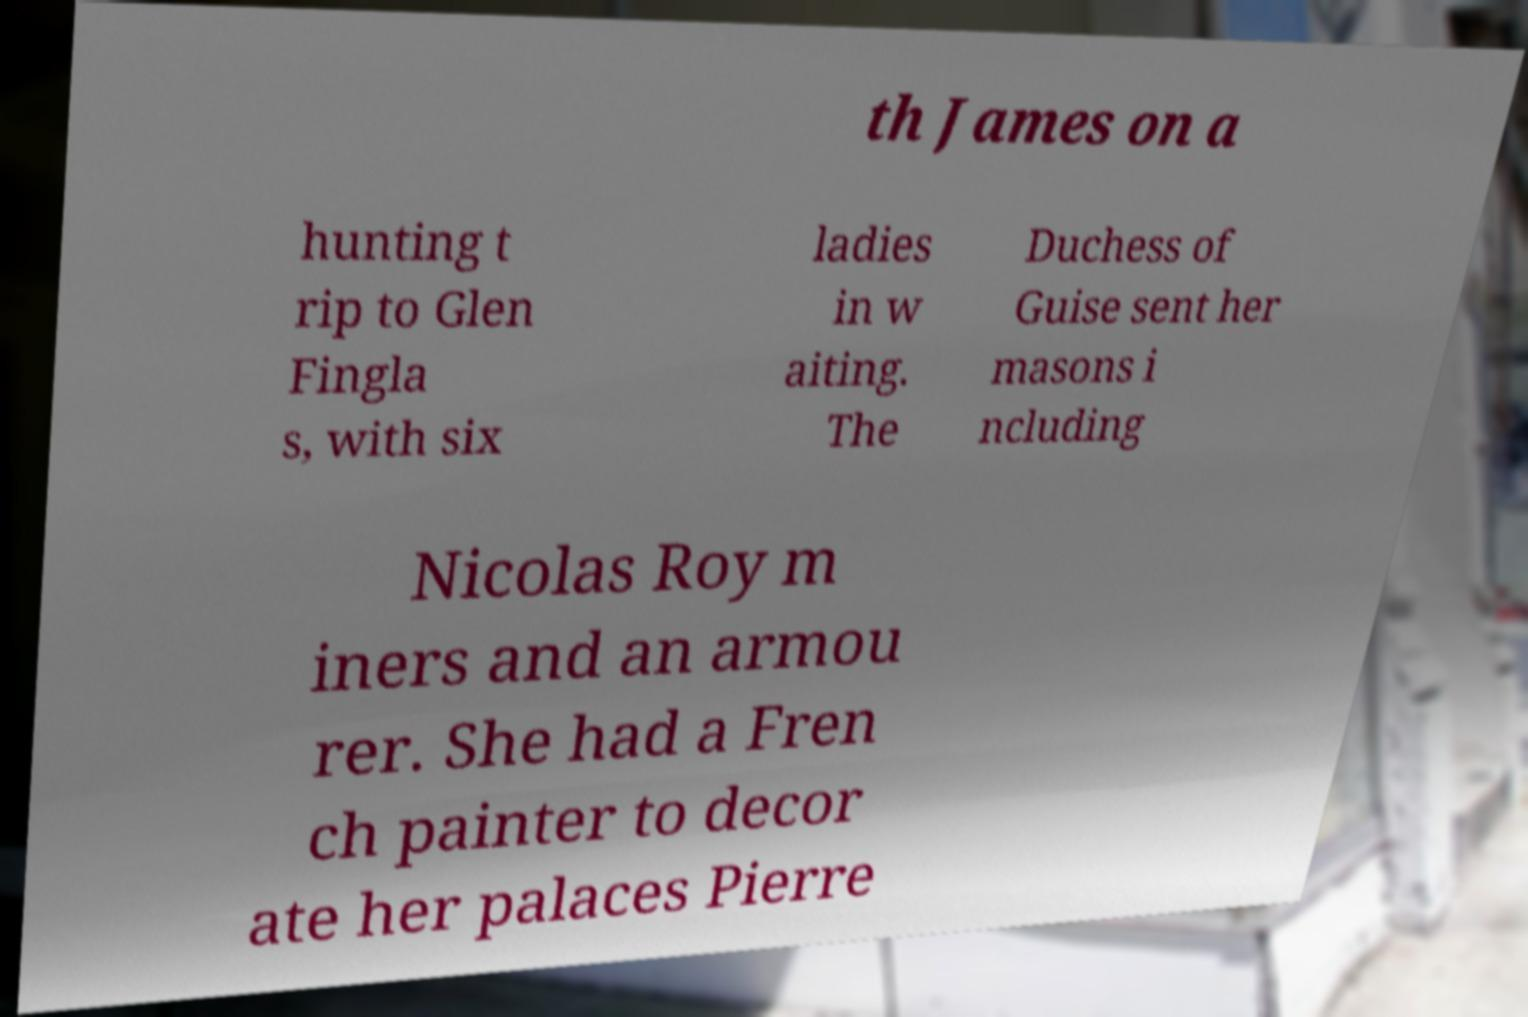There's text embedded in this image that I need extracted. Can you transcribe it verbatim? th James on a hunting t rip to Glen Fingla s, with six ladies in w aiting. The Duchess of Guise sent her masons i ncluding Nicolas Roy m iners and an armou rer. She had a Fren ch painter to decor ate her palaces Pierre 